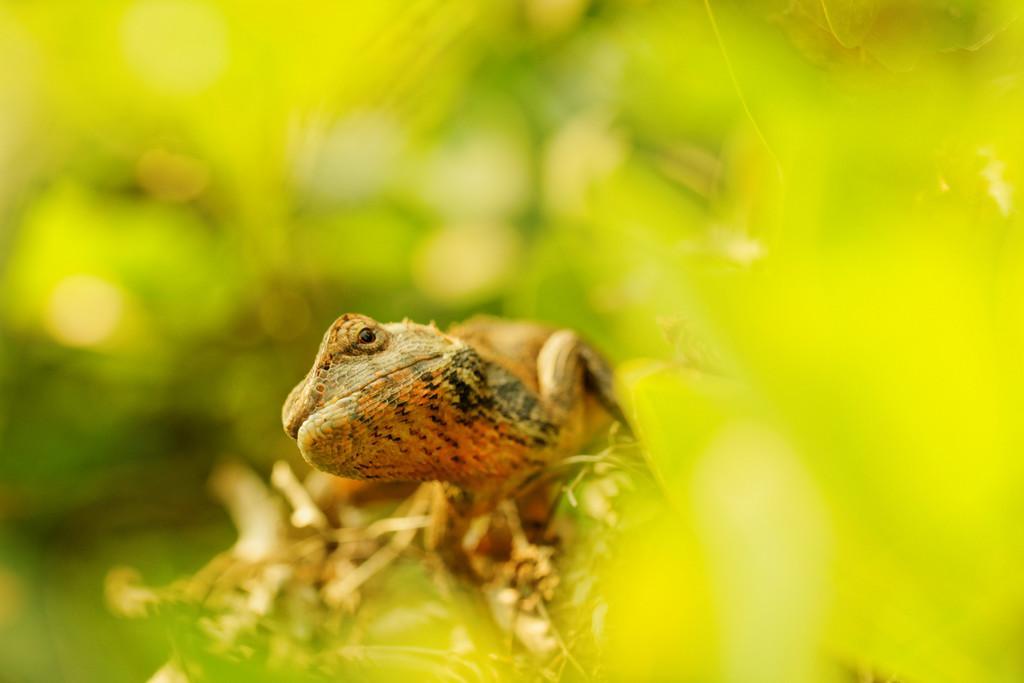Could you give a brief overview of what you see in this image? In this image there is a reptile on the plant having few leaves. Background there are few plants. 